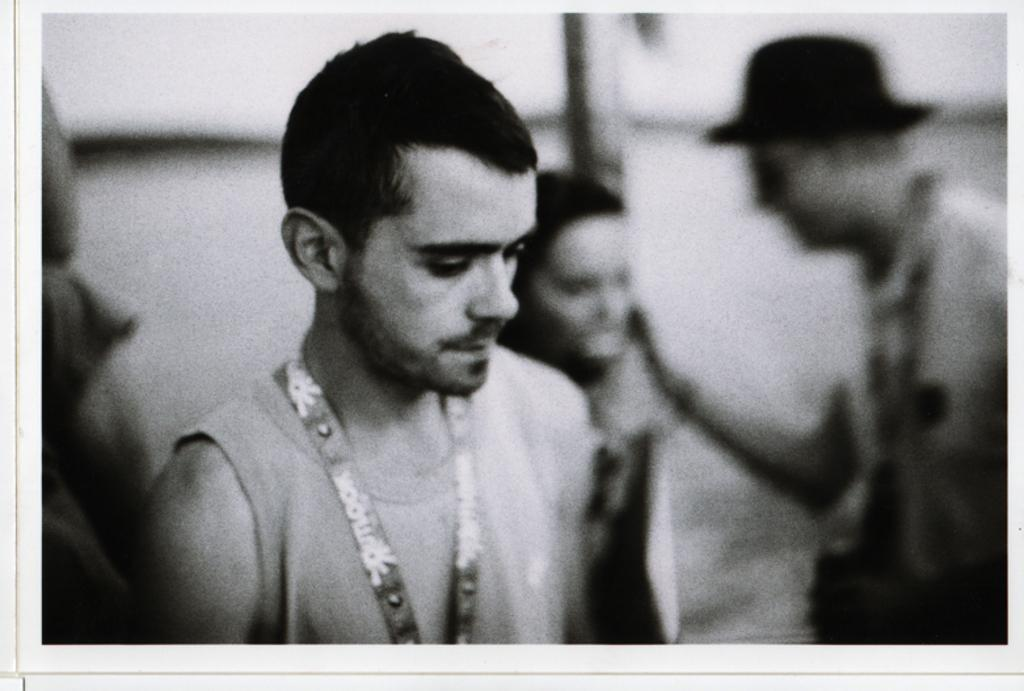Who is the main subject on the left side of the image? There is a boy on the left side of the image. Where are the other people located in the image? The other people are on the right side of the image. What type of branch can be seen growing from the boy's ear in the image? There is no branch growing from the boy's ear in the image. 